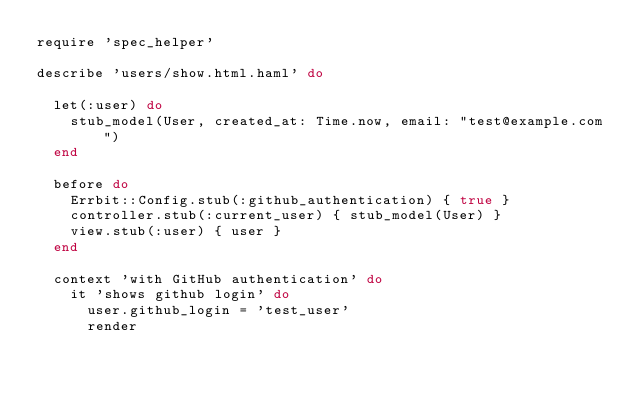<code> <loc_0><loc_0><loc_500><loc_500><_Ruby_>require 'spec_helper'

describe 'users/show.html.haml' do

  let(:user) do
    stub_model(User, created_at: Time.now, email: "test@example.com")
  end

  before do
    Errbit::Config.stub(:github_authentication) { true }
    controller.stub(:current_user) { stub_model(User) }
    view.stub(:user) { user }
  end

  context 'with GitHub authentication' do
    it 'shows github login' do
      user.github_login = 'test_user'
      render</code> 